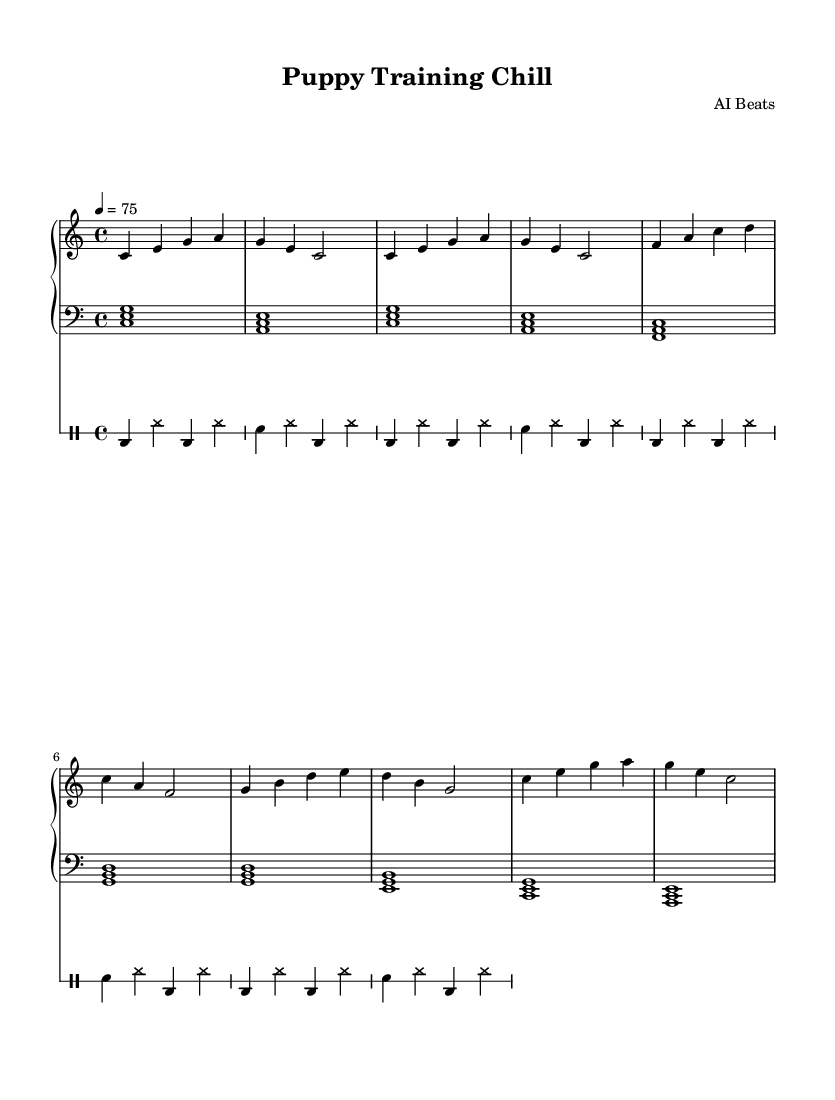What is the key signature of this music? The key signature indicates the key of C major, which has no sharps or flats, as observed from the absence of any sharp or flat symbols at the beginning of the staff.
Answer: C major What is the time signature of this music? The time signature is 4/4, which means there are four beats in each measure, as evidenced by the "4/4" notation found directly after the key signature.
Answer: 4/4 What is the tempo marking for this piece? The tempo marking shows a beat rate of 75, indicated by "4 = 75," meaning that the quarter note (4) is equal to 75 beats per minute.
Answer: 75 How many measures are in the chorus section? The chorus section consists of two measures, as seen in the repeated section labeled "Chorus," which contains two distinct musical phrases spanning two full measures.
Answer: 2 What instrument primarily plays the melody in this arrangement? The piano is the primary instrument playing the melody, as indicated by the "PianoStaff" designation and the presence of both right-hand (upper) and left-hand (lower) parts.
Answer: Piano What is the drum pattern used in this piece? The drum pattern consists of a combination of bass drum (bd) and snare drum (sn), played in a repeated rhythm that contributes to the hip-hop style of the music.
Answer: Bass and snare How does the piano left-hand part contribute to the feel of the piece? The left-hand part plays chords that add harmonic support and depth, contributing to the chill and relaxing ambiance typical of lo-fi hip-hop, as noted by the chord structures that reflect foundational harmonies.
Answer: Chordal harmony 